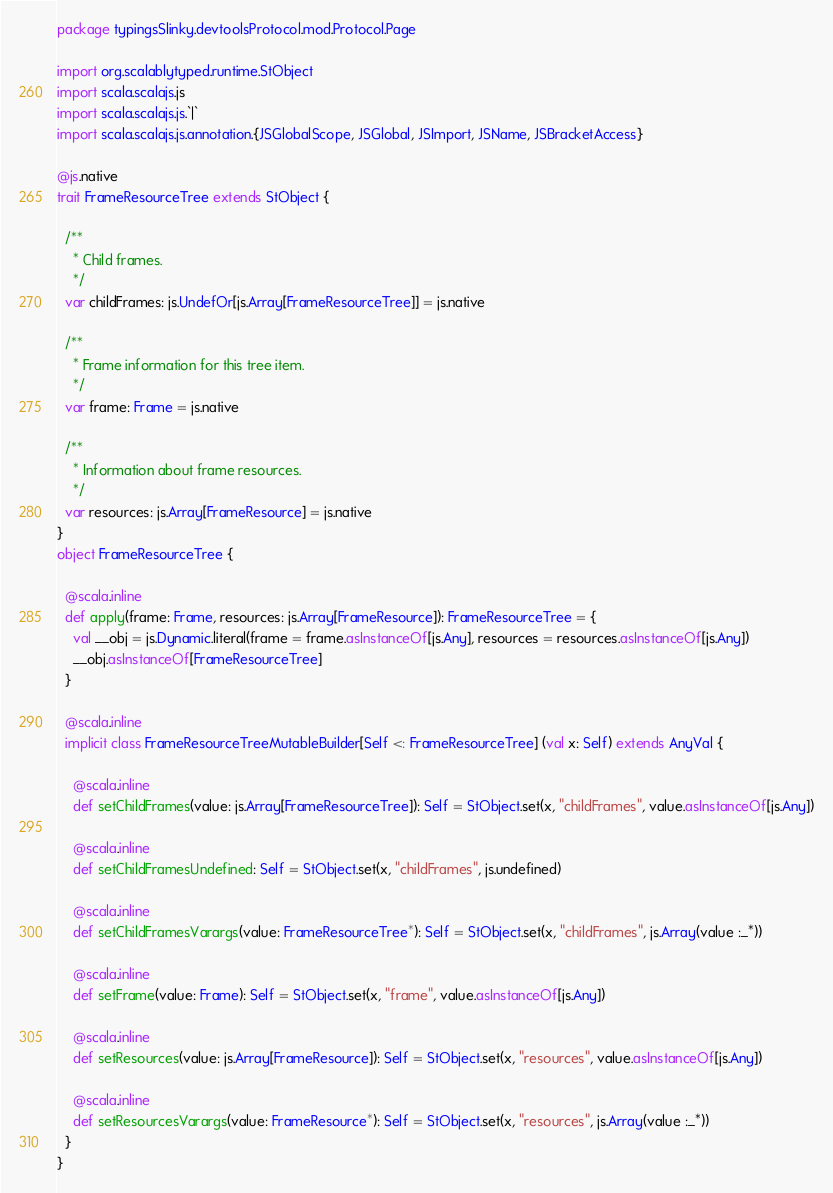Convert code to text. <code><loc_0><loc_0><loc_500><loc_500><_Scala_>package typingsSlinky.devtoolsProtocol.mod.Protocol.Page

import org.scalablytyped.runtime.StObject
import scala.scalajs.js
import scala.scalajs.js.`|`
import scala.scalajs.js.annotation.{JSGlobalScope, JSGlobal, JSImport, JSName, JSBracketAccess}

@js.native
trait FrameResourceTree extends StObject {
  
  /**
    * Child frames.
    */
  var childFrames: js.UndefOr[js.Array[FrameResourceTree]] = js.native
  
  /**
    * Frame information for this tree item.
    */
  var frame: Frame = js.native
  
  /**
    * Information about frame resources.
    */
  var resources: js.Array[FrameResource] = js.native
}
object FrameResourceTree {
  
  @scala.inline
  def apply(frame: Frame, resources: js.Array[FrameResource]): FrameResourceTree = {
    val __obj = js.Dynamic.literal(frame = frame.asInstanceOf[js.Any], resources = resources.asInstanceOf[js.Any])
    __obj.asInstanceOf[FrameResourceTree]
  }
  
  @scala.inline
  implicit class FrameResourceTreeMutableBuilder[Self <: FrameResourceTree] (val x: Self) extends AnyVal {
    
    @scala.inline
    def setChildFrames(value: js.Array[FrameResourceTree]): Self = StObject.set(x, "childFrames", value.asInstanceOf[js.Any])
    
    @scala.inline
    def setChildFramesUndefined: Self = StObject.set(x, "childFrames", js.undefined)
    
    @scala.inline
    def setChildFramesVarargs(value: FrameResourceTree*): Self = StObject.set(x, "childFrames", js.Array(value :_*))
    
    @scala.inline
    def setFrame(value: Frame): Self = StObject.set(x, "frame", value.asInstanceOf[js.Any])
    
    @scala.inline
    def setResources(value: js.Array[FrameResource]): Self = StObject.set(x, "resources", value.asInstanceOf[js.Any])
    
    @scala.inline
    def setResourcesVarargs(value: FrameResource*): Self = StObject.set(x, "resources", js.Array(value :_*))
  }
}
</code> 